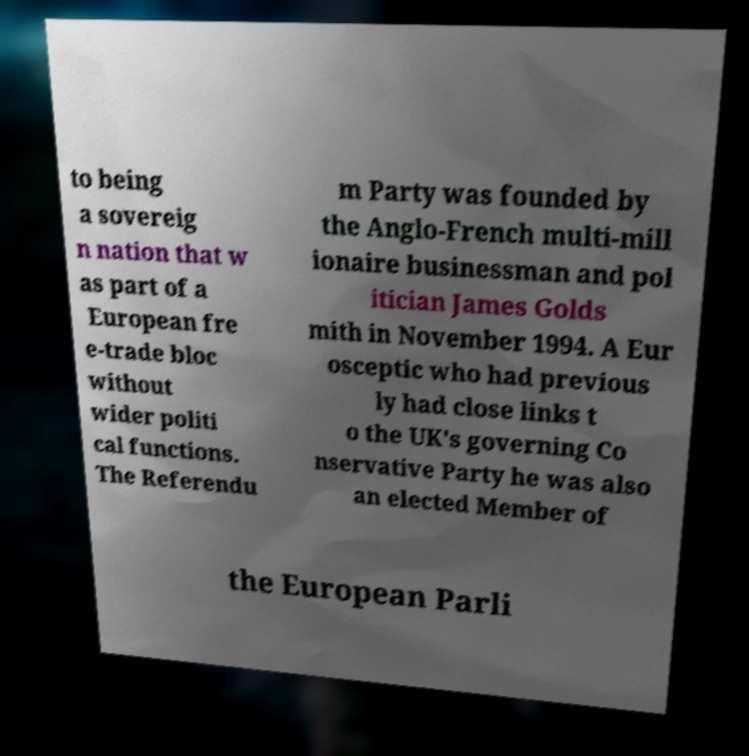For documentation purposes, I need the text within this image transcribed. Could you provide that? to being a sovereig n nation that w as part of a European fre e-trade bloc without wider politi cal functions. The Referendu m Party was founded by the Anglo-French multi-mill ionaire businessman and pol itician James Golds mith in November 1994. A Eur osceptic who had previous ly had close links t o the UK's governing Co nservative Party he was also an elected Member of the European Parli 